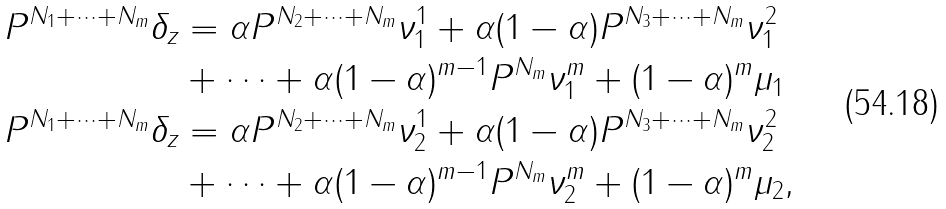<formula> <loc_0><loc_0><loc_500><loc_500>P ^ { N _ { 1 } + \cdots + N _ { m } } \delta _ { z } & = \alpha P ^ { N _ { 2 } + \cdots + N _ { m } } \nu _ { 1 } ^ { 1 } + \alpha ( 1 - \alpha ) P ^ { N _ { 3 } + \cdots + N _ { m } } \nu _ { 1 } ^ { 2 } \\ & + \cdots + \alpha ( 1 - \alpha ) ^ { m - 1 } P ^ { N _ { m } } \nu _ { 1 } ^ { m } + ( 1 - \alpha ) ^ { m } \mu _ { 1 } \\ P ^ { N _ { 1 } + \cdots + N _ { m } } \delta _ { z } & = \alpha P ^ { N _ { 2 } + \cdots + N _ { m } } \nu _ { 2 } ^ { 1 } + \alpha ( 1 - \alpha ) P ^ { N _ { 3 } + \cdots + N _ { m } } \nu _ { 2 } ^ { 2 } \\ & + \cdots + \alpha ( 1 - \alpha ) ^ { m - 1 } P ^ { N _ { m } } \nu _ { 2 } ^ { m } + ( 1 - \alpha ) ^ { m } \mu _ { 2 } ,</formula> 